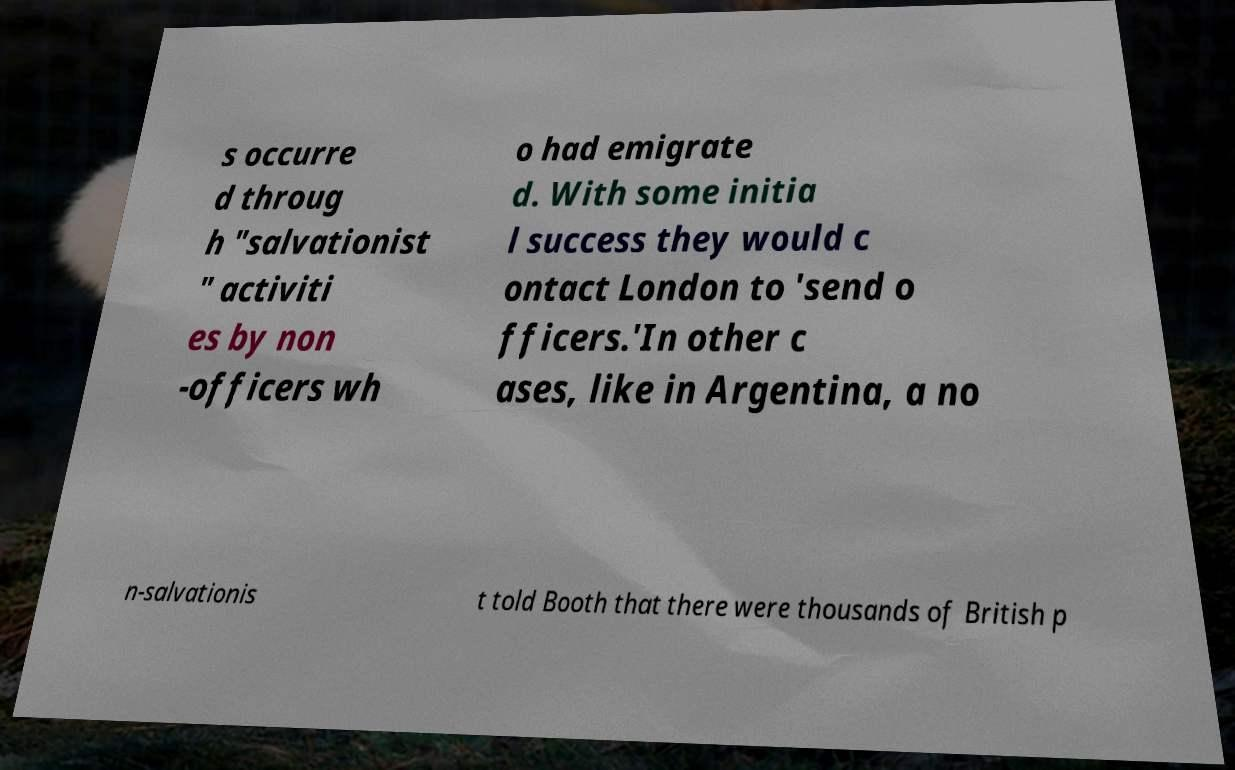Could you assist in decoding the text presented in this image and type it out clearly? s occurre d throug h "salvationist " activiti es by non -officers wh o had emigrate d. With some initia l success they would c ontact London to 'send o fficers.'In other c ases, like in Argentina, a no n-salvationis t told Booth that there were thousands of British p 